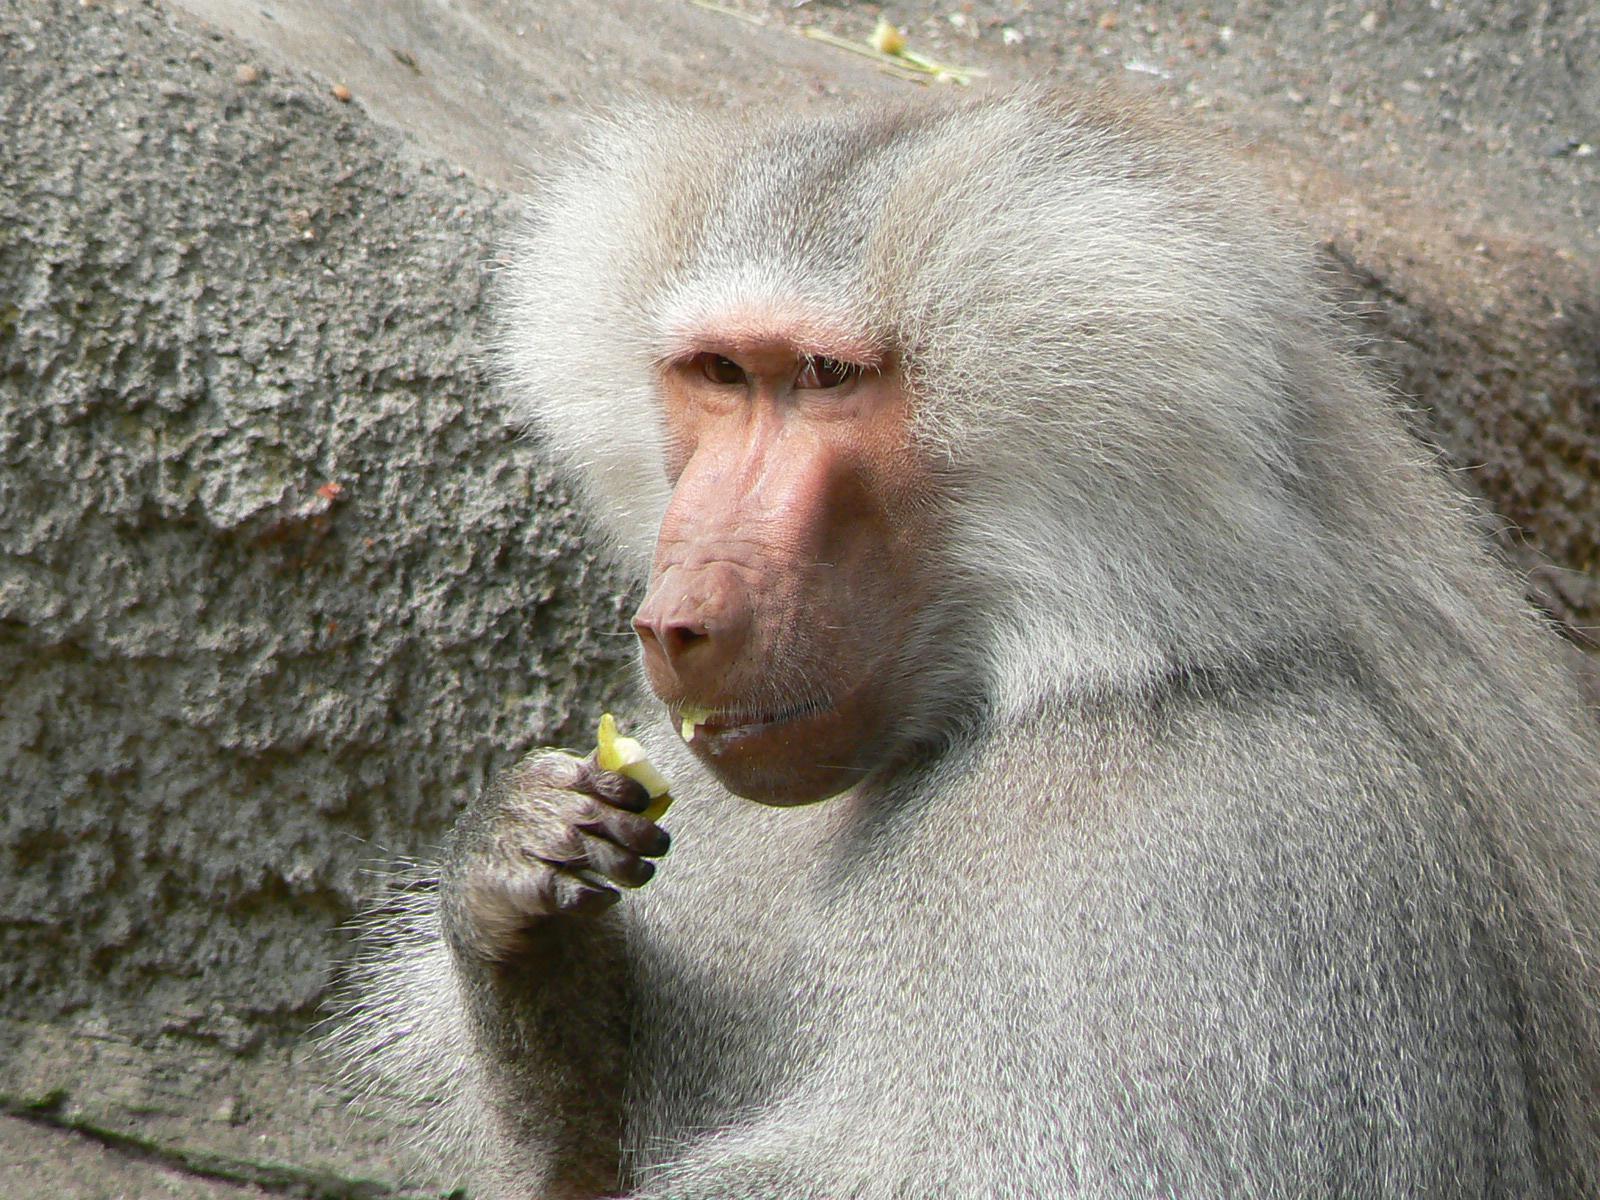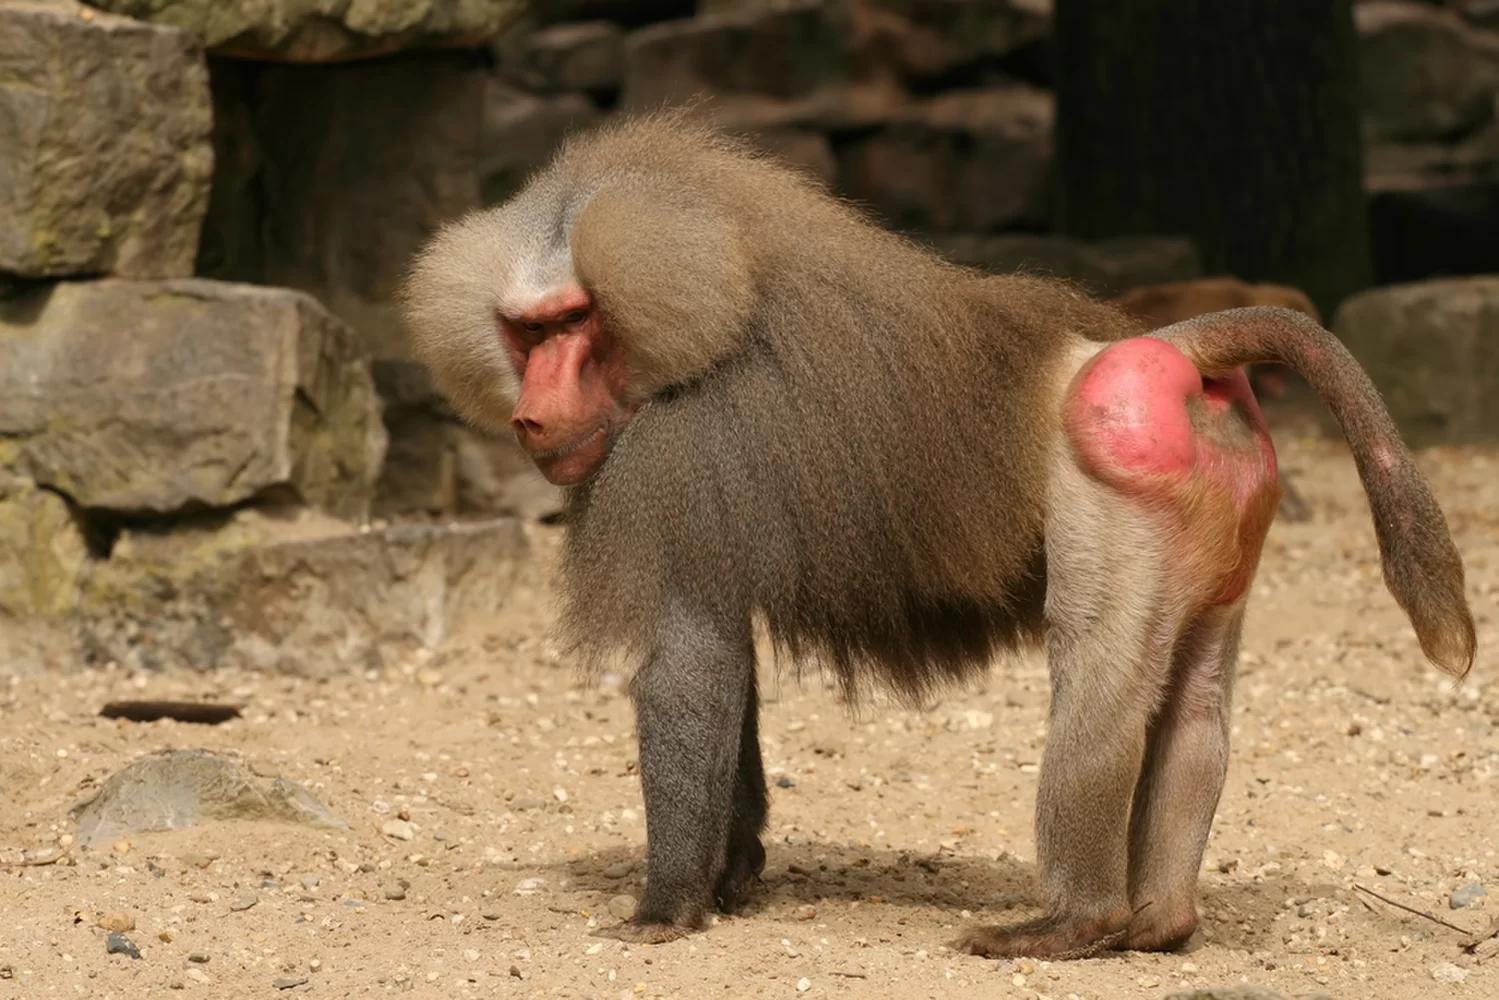The first image is the image on the left, the second image is the image on the right. Analyze the images presented: Is the assertion "An image shows a baboon standing on all fours with part of its bulbous pink hairless rear showing." valid? Answer yes or no. Yes. The first image is the image on the left, the second image is the image on the right. Assess this claim about the two images: "The primate in the image on the left has greyish whitish hair.". Correct or not? Answer yes or no. Yes. 